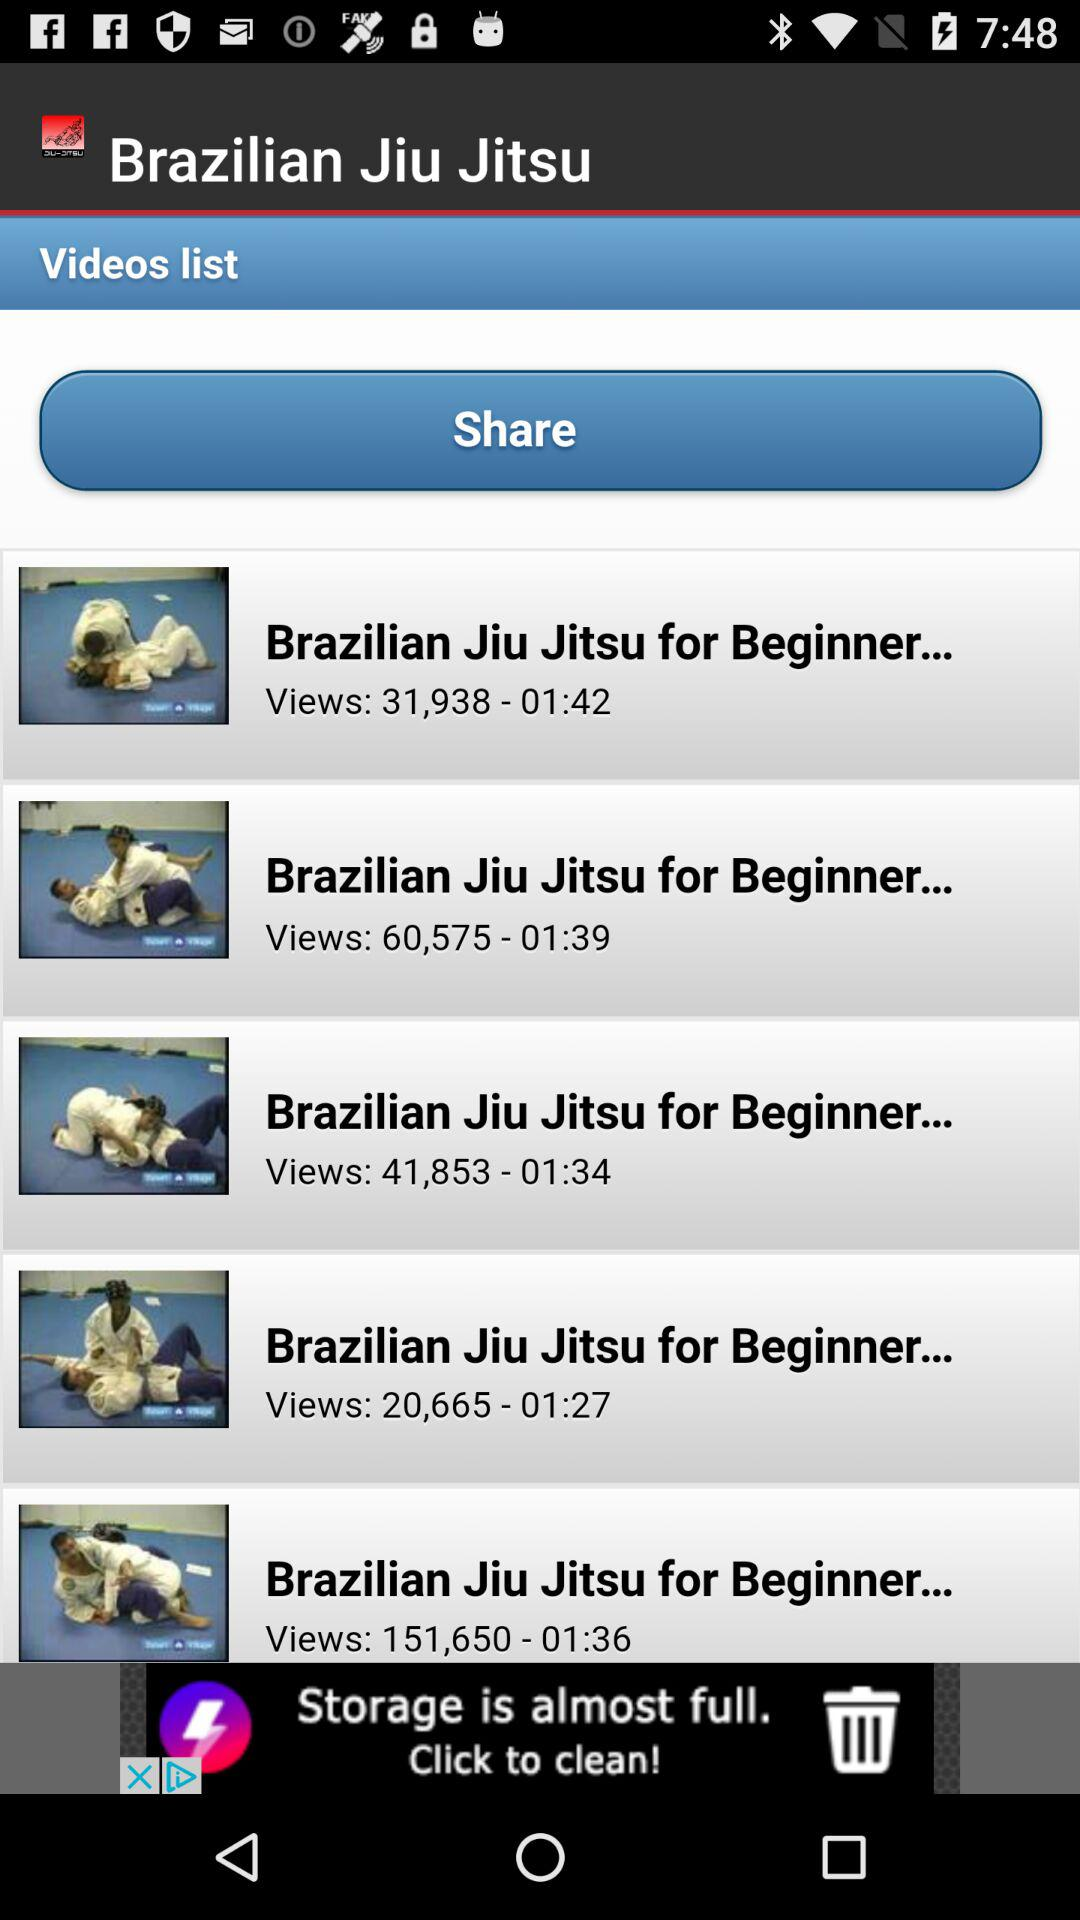What is the name of the application? The name of the application is "Brazilian Jiu Jitsu". 